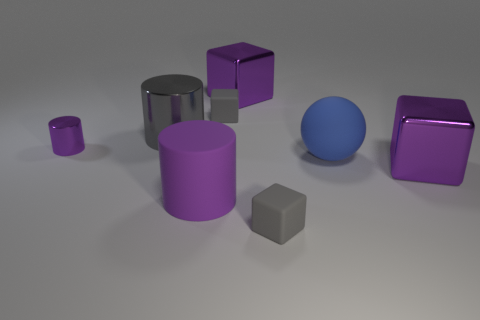Subtract all red blocks. How many purple cylinders are left? 2 Subtract 1 cylinders. How many cylinders are left? 2 Subtract all blue blocks. Subtract all blue spheres. How many blocks are left? 4 Add 2 green things. How many objects exist? 10 Subtract all metal cylinders. Subtract all tiny blue cubes. How many objects are left? 6 Add 5 purple cylinders. How many purple cylinders are left? 7 Add 8 small gray cubes. How many small gray cubes exist? 10 Subtract 0 green cubes. How many objects are left? 8 Subtract all cylinders. How many objects are left? 5 